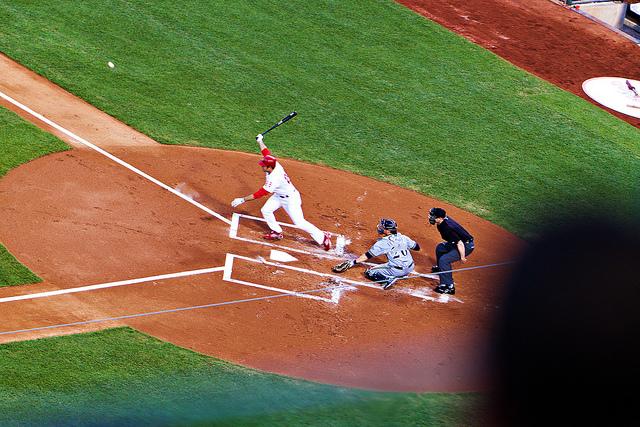Does this look like a hockey game?
Write a very short answer. No. What color is the uniform?
Keep it brief. White. Is the batter's box freshly chalked?
Short answer required. Yes. Is the batter standing still?
Be succinct. No. 